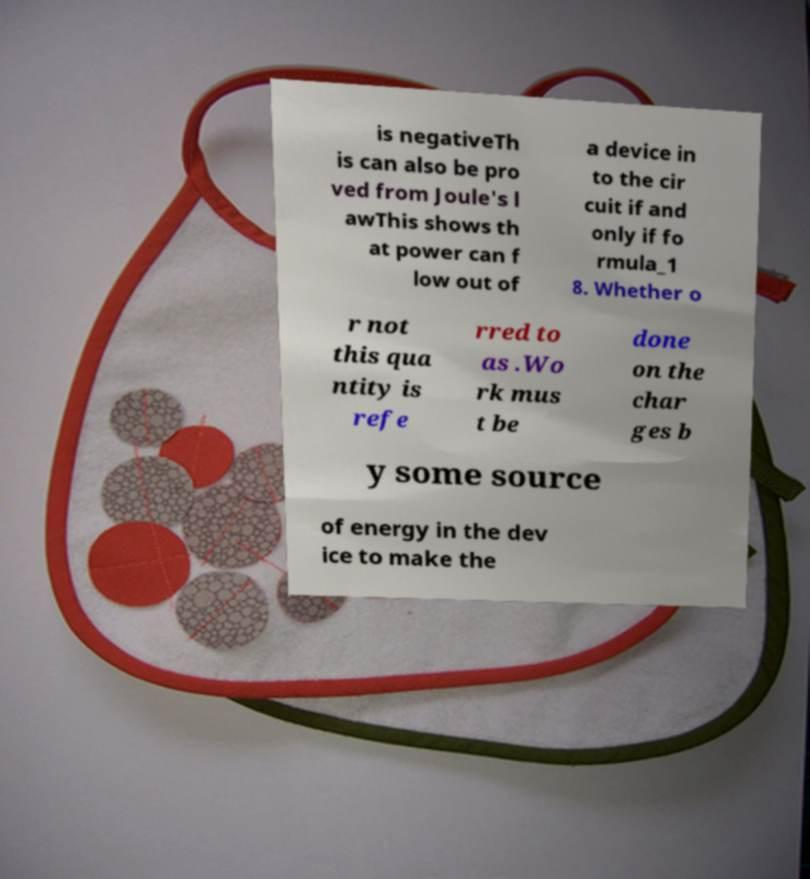Can you accurately transcribe the text from the provided image for me? is negativeTh is can also be pro ved from Joule's l awThis shows th at power can f low out of a device in to the cir cuit if and only if fo rmula_1 8. Whether o r not this qua ntity is refe rred to as .Wo rk mus t be done on the char ges b y some source of energy in the dev ice to make the 